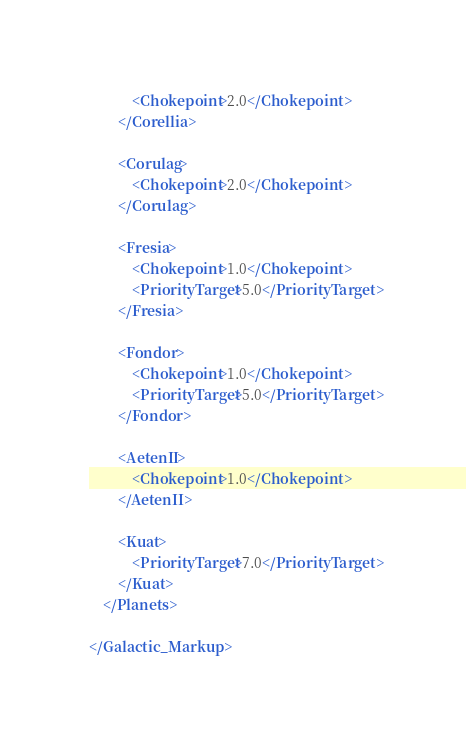<code> <loc_0><loc_0><loc_500><loc_500><_XML_>			<Chokepoint>2.0</Chokepoint>
		</Corellia>
		
		<Corulag>
			<Chokepoint>2.0</Chokepoint>
		</Corulag>
		
		<Fresia>
			<Chokepoint>1.0</Chokepoint>
			<PriorityTarget>5.0</PriorityTarget>
		</Fresia>
		
		<Fondor>
			<Chokepoint>1.0</Chokepoint>
			<PriorityTarget>5.0</PriorityTarget>
		</Fondor>
		
		<AetenII>
			<Chokepoint>1.0</Chokepoint>
		</AetenII>
		
		<Kuat>
			<PriorityTarget>7.0</PriorityTarget>
		</Kuat>
	</Planets>
	
</Galactic_Markup>
</code> 